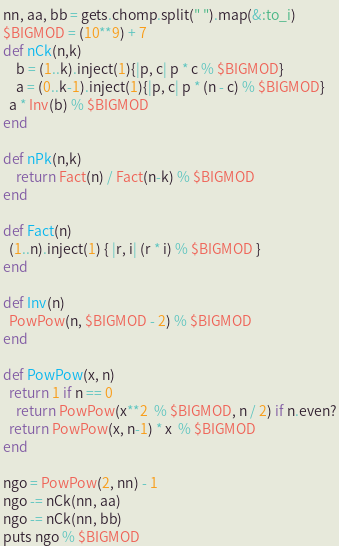<code> <loc_0><loc_0><loc_500><loc_500><_Ruby_>nn, aa, bb = gets.chomp.split(" ").map(&:to_i)
$BIGMOD = (10**9) + 7
def nCk(n,k)
	b = (1..k).inject(1){|p, c| p * c % $BIGMOD}
	a = (0..k-1).inject(1){|p, c| p * (n - c) % $BIGMOD}
  a * Inv(b) % $BIGMOD
end

def nPk(n,k)
	return Fact(n) / Fact(n-k) % $BIGMOD
end

def Fact(n)
  (1..n).inject(1) { |r, i| (r * i) % $BIGMOD }
end

def Inv(n)
  PowPow(n, $BIGMOD - 2) % $BIGMOD
end

def PowPow(x, n)
  return 1 if n == 0
	return PowPow(x**2  % $BIGMOD, n / 2) if n.even?
  return PowPow(x, n-1) * x  % $BIGMOD 
end

ngo = PowPow(2, nn) - 1
ngo -= nCk(nn, aa)
ngo -= nCk(nn, bb)
puts ngo % $BIGMOD
</code> 